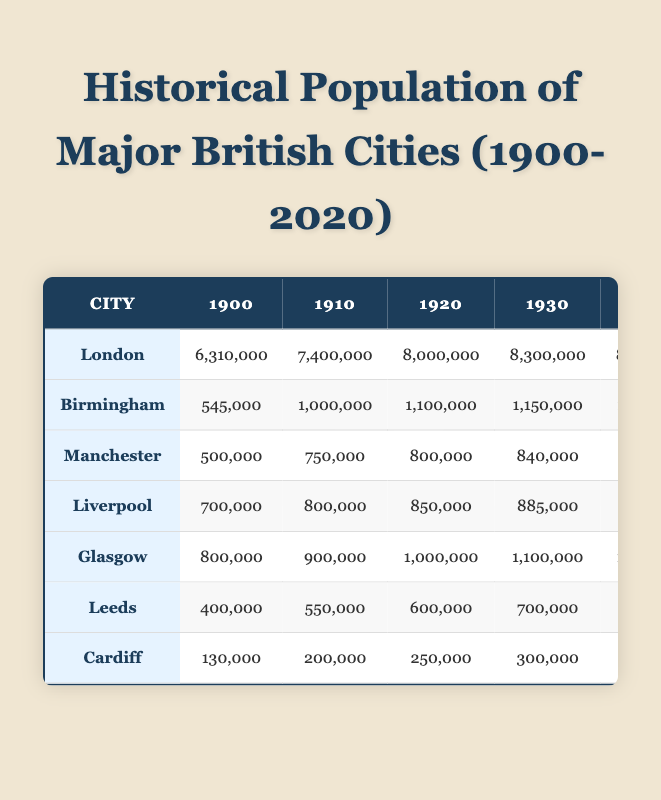What was the population of London in 1960? In the table, under the column for London, the value corresponding to the year 1960 is 8,000,000.
Answer: 8,000,000 What year did Birmingham first exceed a population of 1,000,000? The table shows that Birmingham's population first exceeded 1,000,000 in 1910, as this is the first year with a recorded population of 1,000,000 or more.
Answer: 1910 By how much did the population of Manchester decrease from 1970 to 1990? The population in 1970 was 600,000 and in 1990 it was 450,000. The decrease is calculated as 600,000 - 450,000 = 150,000.
Answer: 150,000 Which city had the highest population in 2020? Referring to the table, London has the highest population in 2020 at 9,000,000, while other cities have lower populations.
Answer: London What is the average population of Glasgow from 1950 to 2020? To find the average, add the populations from those years: 850,000 (1950) + 800,000 (1960) + 700,000 (1970) + 600,000 (1980) + 610,000 (1990) + 600,000 (2000) + 600,000 (2010) + 633,000 (2020) = 4,593,000. There are 8 values, so the average is 4,593,000 divided by 8, which equals 574,125.
Answer: 574,125 Was there a population growth in Liverpool from 2010 to 2020? In 2010, Liverpool's population was 466,000, and in 2020 it was 498,000. Since 498,000 is greater than 466,000, this indicates there was growth.
Answer: Yes Which city saw a population decline from 1950 to 1960? Looking at the populations, Birmingham went from 1,100,000 in 1950 to 1,000,000 in 1960, indicating a decline, as did Glasgow from 850,000 to 800,000. Both cities experienced a decline in population.
Answer: Birmingham and Glasgow What was the population of Cardiff in 2000? The population of Cardiff in the year 2000 is listed in the table as 305,000.
Answer: 305,000 How many cities had a population of over 1,000,000 in 1930? Referring to the table, in 1930 London (8,300,000), Birmingham (1,150,000), and Glasgow (1,100,000) all had populations over 1,000,000. That makes a total of three cities.
Answer: 3 What is the total population of Leeds from 1900 to 2020? Adding the populations from each year: 400,000 (1900) + 550,000 (1910) + 600,000 (1920) + 700,000 (1930) + 740,000 (1940) + 740,000 (1950) + 800,000 (1960) + 750,000 (1970) + 700,000 (1980) + 700,000 (1990) + 700,000 (2000) + 793,000 (2010) + 800,000 (2020) gives a total of 8,983,000.
Answer: 8,983,000 Which city had the lowest population in 1990? Looking at the populations in 1990, Liverpool had the lowest population at 380,000 compared to the others.
Answer: Liverpool 